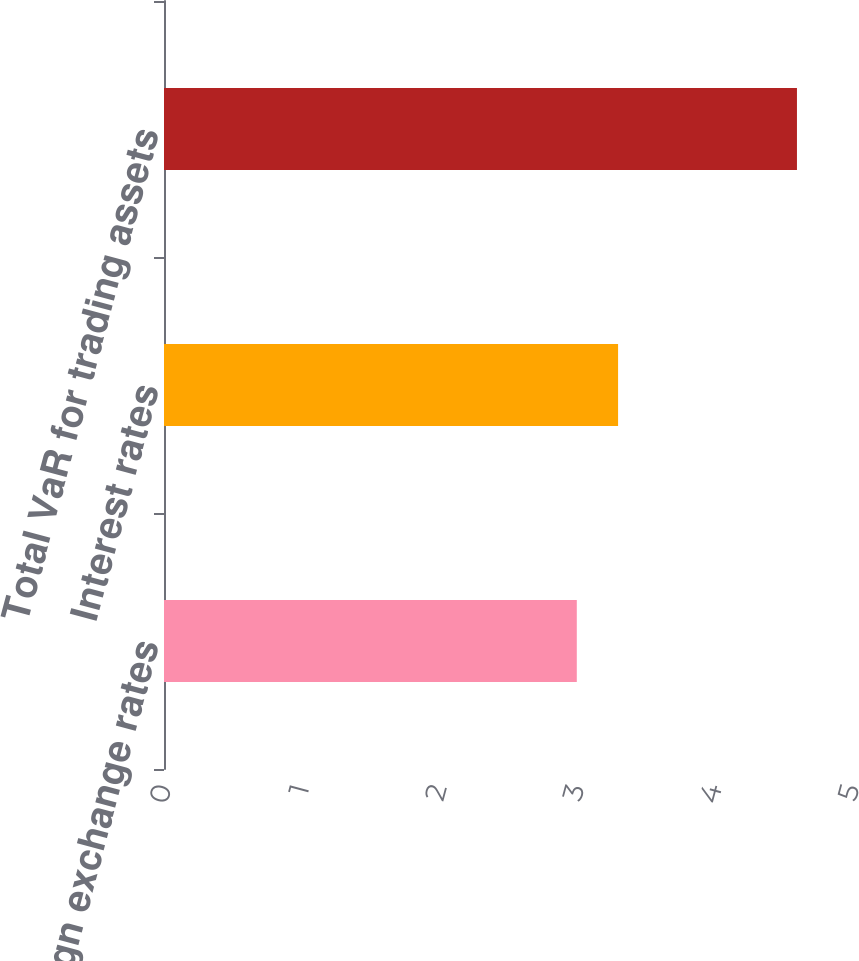Convert chart. <chart><loc_0><loc_0><loc_500><loc_500><bar_chart><fcel>Foreign exchange rates<fcel>Interest rates<fcel>Total VaR for trading assets<nl><fcel>3<fcel>3.3<fcel>4.6<nl></chart> 